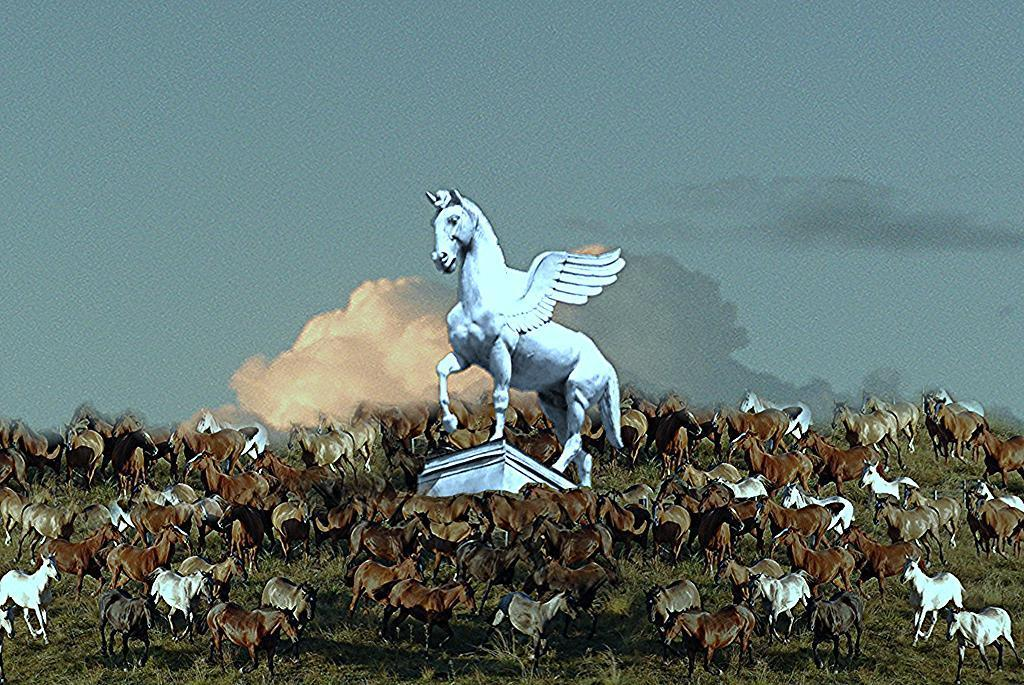What is the main subject in the middle of the image? There is a horse statue in the middle of the image. What else can be seen on the ground in the image? There are herds of horses on the ground. What is visible in the background of the image? The sky is visible in the background of the image. Can you describe the time of day the image may have been taken? The image may have been taken in the evening, as suggested by the lighting. How many feet are visible in the image? There are no feet visible in the image, as it features a horse statue and herds of horses. 